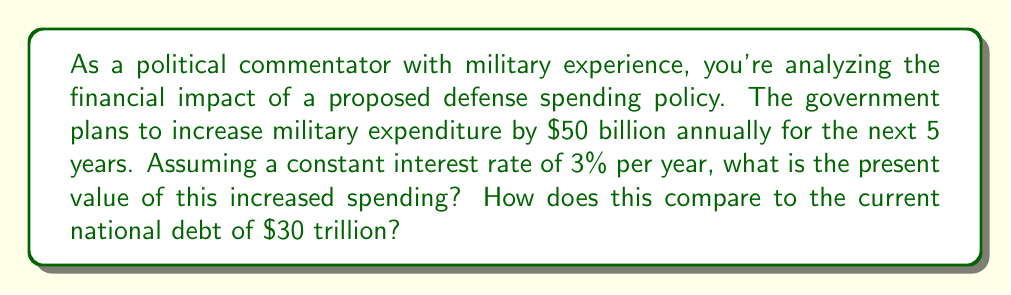Can you solve this math problem? To solve this problem, we need to use the concept of present value for an annuity. The formula for the present value of an annuity is:

$$ PV = PMT \times \frac{1 - (1 + r)^{-n}}{r} $$

Where:
$PV$ = Present Value
$PMT$ = Payment (annual increase in spending)
$r$ = Interest rate
$n$ = Number of periods

Given:
$PMT = \$50 \text{ billion}$
$r = 3\% = 0.03$
$n = 5 \text{ years}$

Let's calculate step by step:

1) Substitute the values into the formula:

   $$ PV = 50 \times \frac{1 - (1 + 0.03)^{-5}}{0.03} $$

2) Calculate $(1 + 0.03)^{-5}$:
   
   $$ (1.03)^{-5} = 0.8626 $$

3) Subtract this from 1:
   
   $$ 1 - 0.8626 = 0.1374 $$

4) Divide by 0.03:
   
   $$ \frac{0.1374}{0.03} = 4.5800 $$

5) Multiply by 50:
   
   $$ 50 \times 4.5800 = 229 $$

Therefore, the present value of the increased spending is $229 billion.

To compare this to the current national debt:

$$ \frac{229}{30,000} \times 100\% = 0.763\% $$

The present value of the increased spending represents approximately 0.763% of the current national debt.
Answer: The present value of the increased defense spending is $229 billion, which represents approximately 0.763% of the current national debt. 